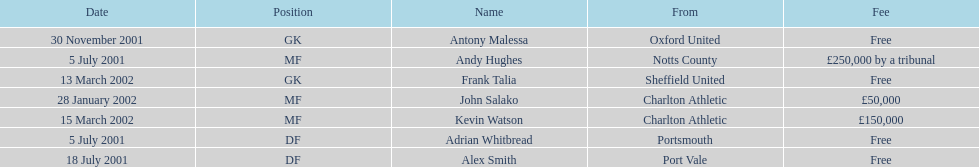Parse the table in full. {'header': ['Date', 'Position', 'Name', 'From', 'Fee'], 'rows': [['30 November 2001', 'GK', 'Antony Malessa', 'Oxford United', 'Free'], ['5 July 2001', 'MF', 'Andy Hughes', 'Notts County', '£250,000 by a tribunal'], ['13 March 2002', 'GK', 'Frank Talia', 'Sheffield United', 'Free'], ['28 January 2002', 'MF', 'John Salako', 'Charlton Athletic', '£50,000'], ['15 March 2002', 'MF', 'Kevin Watson', 'Charlton Athletic', '£150,000'], ['5 July 2001', 'DF', 'Adrian Whitbread', 'Portsmouth', 'Free'], ['18 July 2001', 'DF', 'Alex Smith', 'Port Vale', 'Free']]} What was the transfer fee to transfer kevin watson? £150,000. 